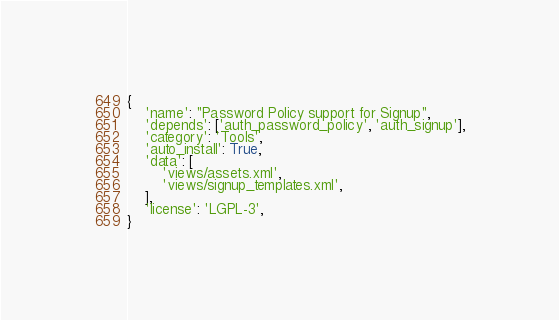Convert code to text. <code><loc_0><loc_0><loc_500><loc_500><_Python_>{
    'name': "Password Policy support for Signup",
    'depends': ['auth_password_policy', 'auth_signup'],
    'category': 'Tools',
    'auto_install': True,
    'data': [
        'views/assets.xml',
        'views/signup_templates.xml',
    ],
    'license': 'LGPL-3',
}
</code> 